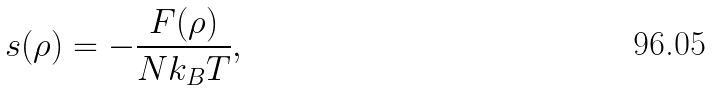<formula> <loc_0><loc_0><loc_500><loc_500>s ( \rho ) = - \frac { F ( \rho ) } { N k _ { B } T } ,</formula> 